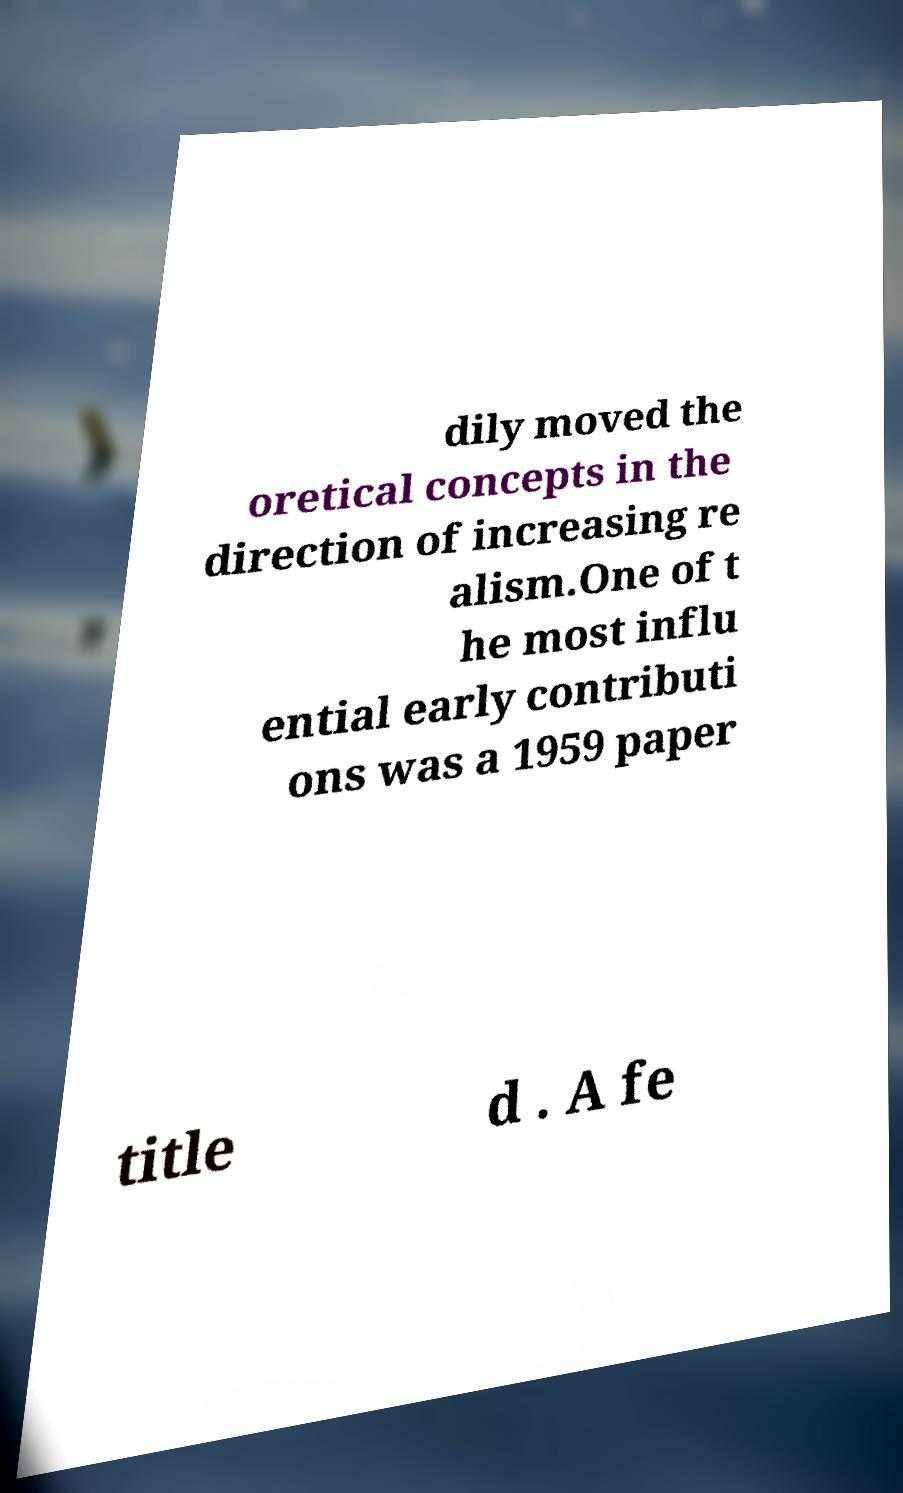Can you accurately transcribe the text from the provided image for me? dily moved the oretical concepts in the direction of increasing re alism.One of t he most influ ential early contributi ons was a 1959 paper title d . A fe 